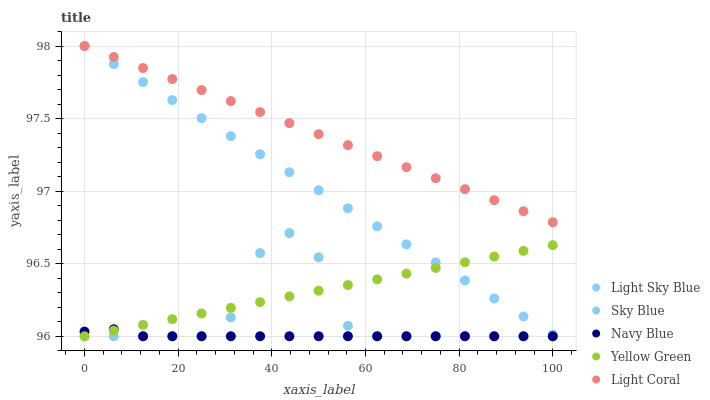Does Navy Blue have the minimum area under the curve?
Answer yes or no. Yes. Does Light Coral have the maximum area under the curve?
Answer yes or no. Yes. Does Sky Blue have the minimum area under the curve?
Answer yes or no. No. Does Sky Blue have the maximum area under the curve?
Answer yes or no. No. Is Yellow Green the smoothest?
Answer yes or no. Yes. Is Sky Blue the roughest?
Answer yes or no. Yes. Is Light Sky Blue the smoothest?
Answer yes or no. No. Is Light Sky Blue the roughest?
Answer yes or no. No. Does Sky Blue have the lowest value?
Answer yes or no. Yes. Does Light Sky Blue have the lowest value?
Answer yes or no. No. Does Light Sky Blue have the highest value?
Answer yes or no. Yes. Does Sky Blue have the highest value?
Answer yes or no. No. Is Navy Blue less than Light Sky Blue?
Answer yes or no. Yes. Is Light Coral greater than Sky Blue?
Answer yes or no. Yes. Does Light Coral intersect Light Sky Blue?
Answer yes or no. Yes. Is Light Coral less than Light Sky Blue?
Answer yes or no. No. Is Light Coral greater than Light Sky Blue?
Answer yes or no. No. Does Navy Blue intersect Light Sky Blue?
Answer yes or no. No. 